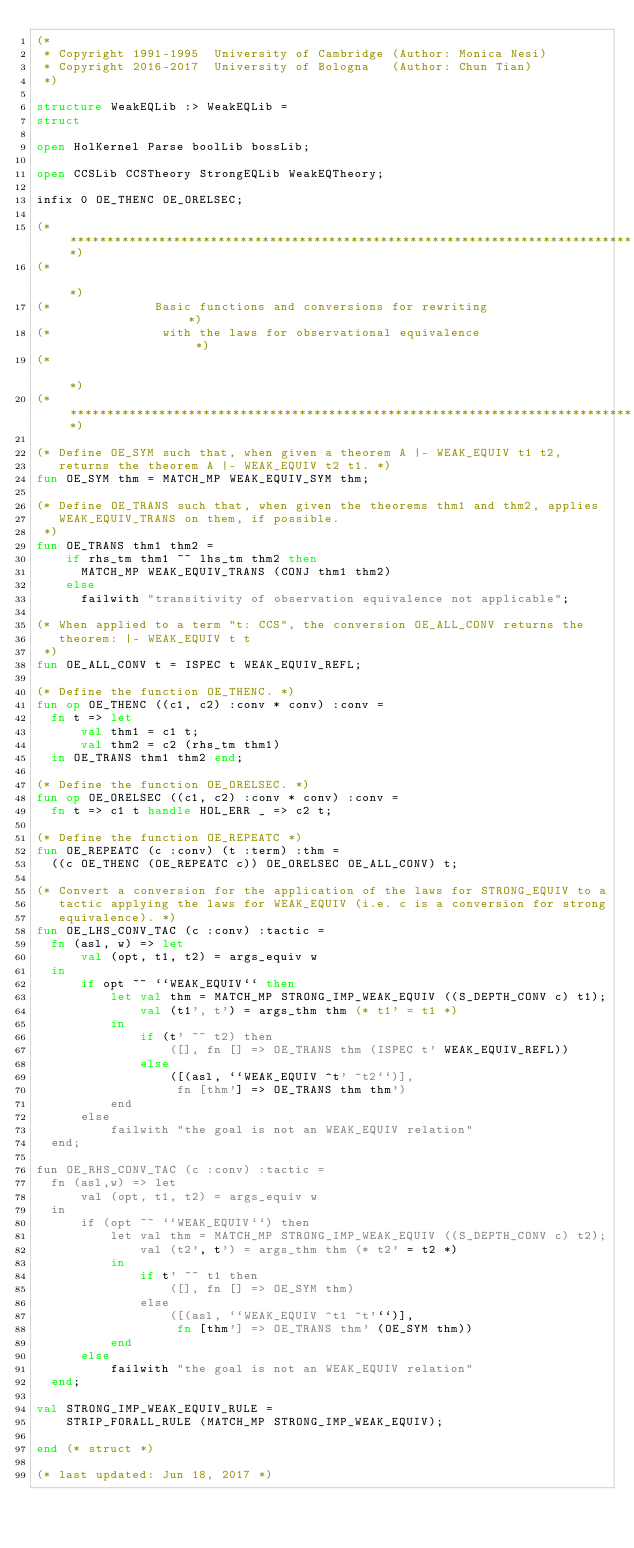Convert code to text. <code><loc_0><loc_0><loc_500><loc_500><_SML_>(*
 * Copyright 1991-1995  University of Cambridge (Author: Monica Nesi)
 * Copyright 2016-2017  University of Bologna   (Author: Chun Tian)
 *)

structure WeakEQLib :> WeakEQLib =
struct

open HolKernel Parse boolLib bossLib;

open CCSLib CCSTheory StrongEQLib WeakEQTheory;

infix 0 OE_THENC OE_ORELSEC;

(******************************************************************************)
(*                                                                            *)
(*              Basic functions and conversions for rewriting                 *)
(*               with the laws for observational equivalence                  *)
(*                                                                            *)
(******************************************************************************)

(* Define OE_SYM such that, when given a theorem A |- WEAK_EQUIV t1 t2,
   returns the theorem A |- WEAK_EQUIV t2 t1. *)
fun OE_SYM thm = MATCH_MP WEAK_EQUIV_SYM thm;

(* Define OE_TRANS such that, when given the theorems thm1 and thm2, applies
   WEAK_EQUIV_TRANS on them, if possible.
 *)
fun OE_TRANS thm1 thm2 =
    if rhs_tm thm1 ~~ lhs_tm thm2 then
      MATCH_MP WEAK_EQUIV_TRANS (CONJ thm1 thm2)
    else
      failwith "transitivity of observation equivalence not applicable";

(* When applied to a term "t: CCS", the conversion OE_ALL_CONV returns the
   theorem: |- WEAK_EQUIV t t
 *)
fun OE_ALL_CONV t = ISPEC t WEAK_EQUIV_REFL;

(* Define the function OE_THENC. *)
fun op OE_THENC ((c1, c2) :conv * conv) :conv =
  fn t => let
      val thm1 = c1 t;
      val thm2 = c2 (rhs_tm thm1)
  in OE_TRANS thm1 thm2 end;

(* Define the function OE_ORELSEC. *)
fun op OE_ORELSEC ((c1, c2) :conv * conv) :conv =
  fn t => c1 t handle HOL_ERR _ => c2 t;

(* Define the function OE_REPEATC *)
fun OE_REPEATC (c :conv) (t :term) :thm =
  ((c OE_THENC (OE_REPEATC c)) OE_ORELSEC OE_ALL_CONV) t;

(* Convert a conversion for the application of the laws for STRONG_EQUIV to a
   tactic applying the laws for WEAK_EQUIV (i.e. c is a conversion for strong
   equivalence). *)
fun OE_LHS_CONV_TAC (c :conv) :tactic =
  fn (asl, w) => let
      val (opt, t1, t2) = args_equiv w
  in
      if opt ~~ ``WEAK_EQUIV`` then
          let val thm = MATCH_MP STRONG_IMP_WEAK_EQUIV ((S_DEPTH_CONV c) t1);
              val (t1', t') = args_thm thm (* t1' = t1 *)
          in
              if (t' ~~ t2) then
                  ([], fn [] => OE_TRANS thm (ISPEC t' WEAK_EQUIV_REFL))
              else
                  ([(asl, ``WEAK_EQUIV ^t' ^t2``)],
                   fn [thm'] => OE_TRANS thm thm')
          end
      else
          failwith "the goal is not an WEAK_EQUIV relation"
  end;

fun OE_RHS_CONV_TAC (c :conv) :tactic =
  fn (asl,w) => let
      val (opt, t1, t2) = args_equiv w
  in
      if (opt ~~ ``WEAK_EQUIV``) then
          let val thm = MATCH_MP STRONG_IMP_WEAK_EQUIV ((S_DEPTH_CONV c) t2);
              val (t2', t') = args_thm thm (* t2' = t2 *)
          in
              if t' ~~ t1 then
                  ([], fn [] => OE_SYM thm)
              else
                  ([(asl, ``WEAK_EQUIV ^t1 ^t'``)],
                   fn [thm'] => OE_TRANS thm' (OE_SYM thm))
          end
      else
          failwith "the goal is not an WEAK_EQUIV relation"
  end;

val STRONG_IMP_WEAK_EQUIV_RULE =
    STRIP_FORALL_RULE (MATCH_MP STRONG_IMP_WEAK_EQUIV);

end (* struct *)

(* last updated: Jun 18, 2017 *)
</code> 